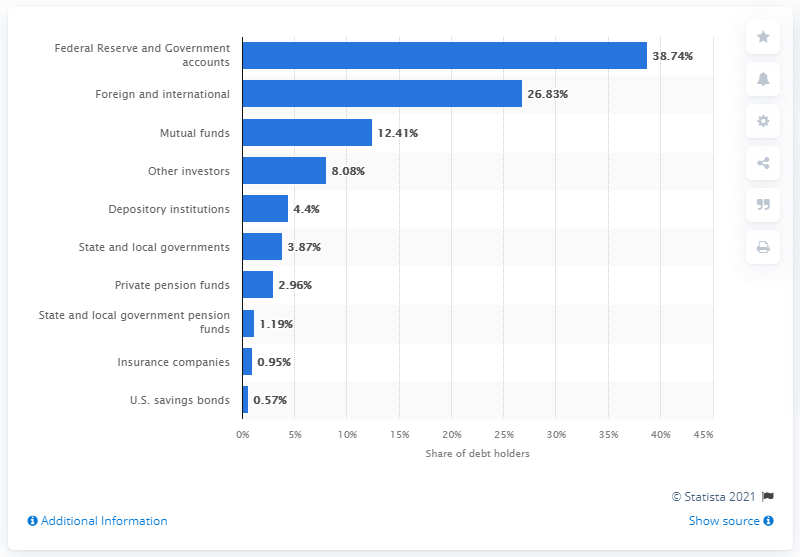Point out several critical features in this image. At the end of 2020, depository institutions owned approximately 4.4% of the total U.S. treasure securities. 